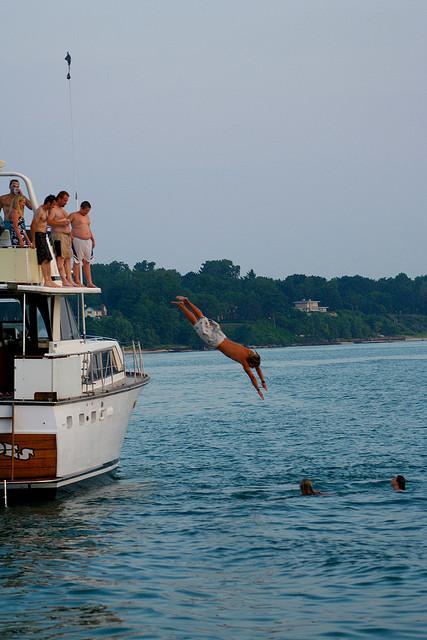What is the boat used for?
Be succinct. Diving. Is a man diving into the water?
Short answer required. Yes. Are there people wearing bandanas?
Quick response, please. No. How many people are on the deck level of the boat?
Write a very short answer. 4. How many people are in the water?
Quick response, please. 2. What color is the bathing suit?
Give a very brief answer. White. How many people are on the bench?
Answer briefly. 0. What color is the water?
Be succinct. Blue. Are they having a party?
Give a very brief answer. Yes. Do these people look like they're going swimming?
Keep it brief. Yes. Is there any people available here?
Give a very brief answer. Yes. What type of boat is pictured here?
Short answer required. Yacht. How many people are on this boat?
Give a very brief answer. 5. Is the boat on water?
Answer briefly. Yes. How many people are in the boat?
Write a very short answer. 4. 